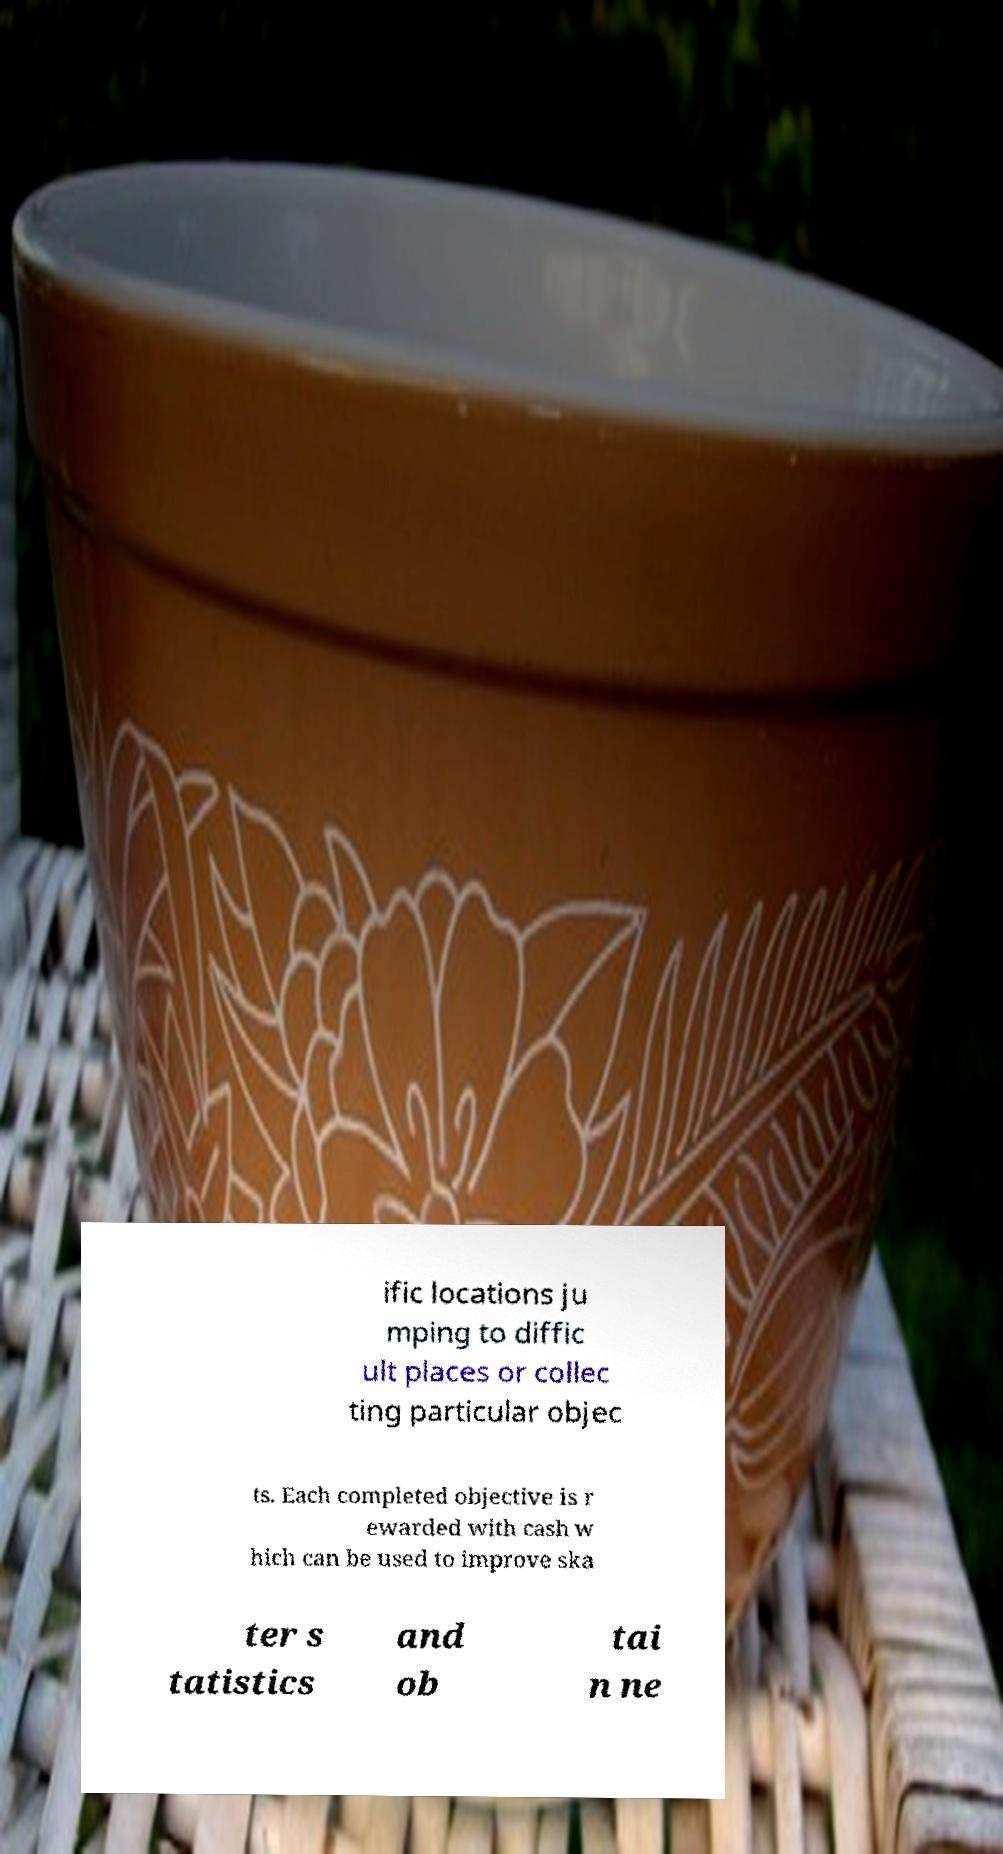Could you extract and type out the text from this image? ific locations ju mping to diffic ult places or collec ting particular objec ts. Each completed objective is r ewarded with cash w hich can be used to improve ska ter s tatistics and ob tai n ne 